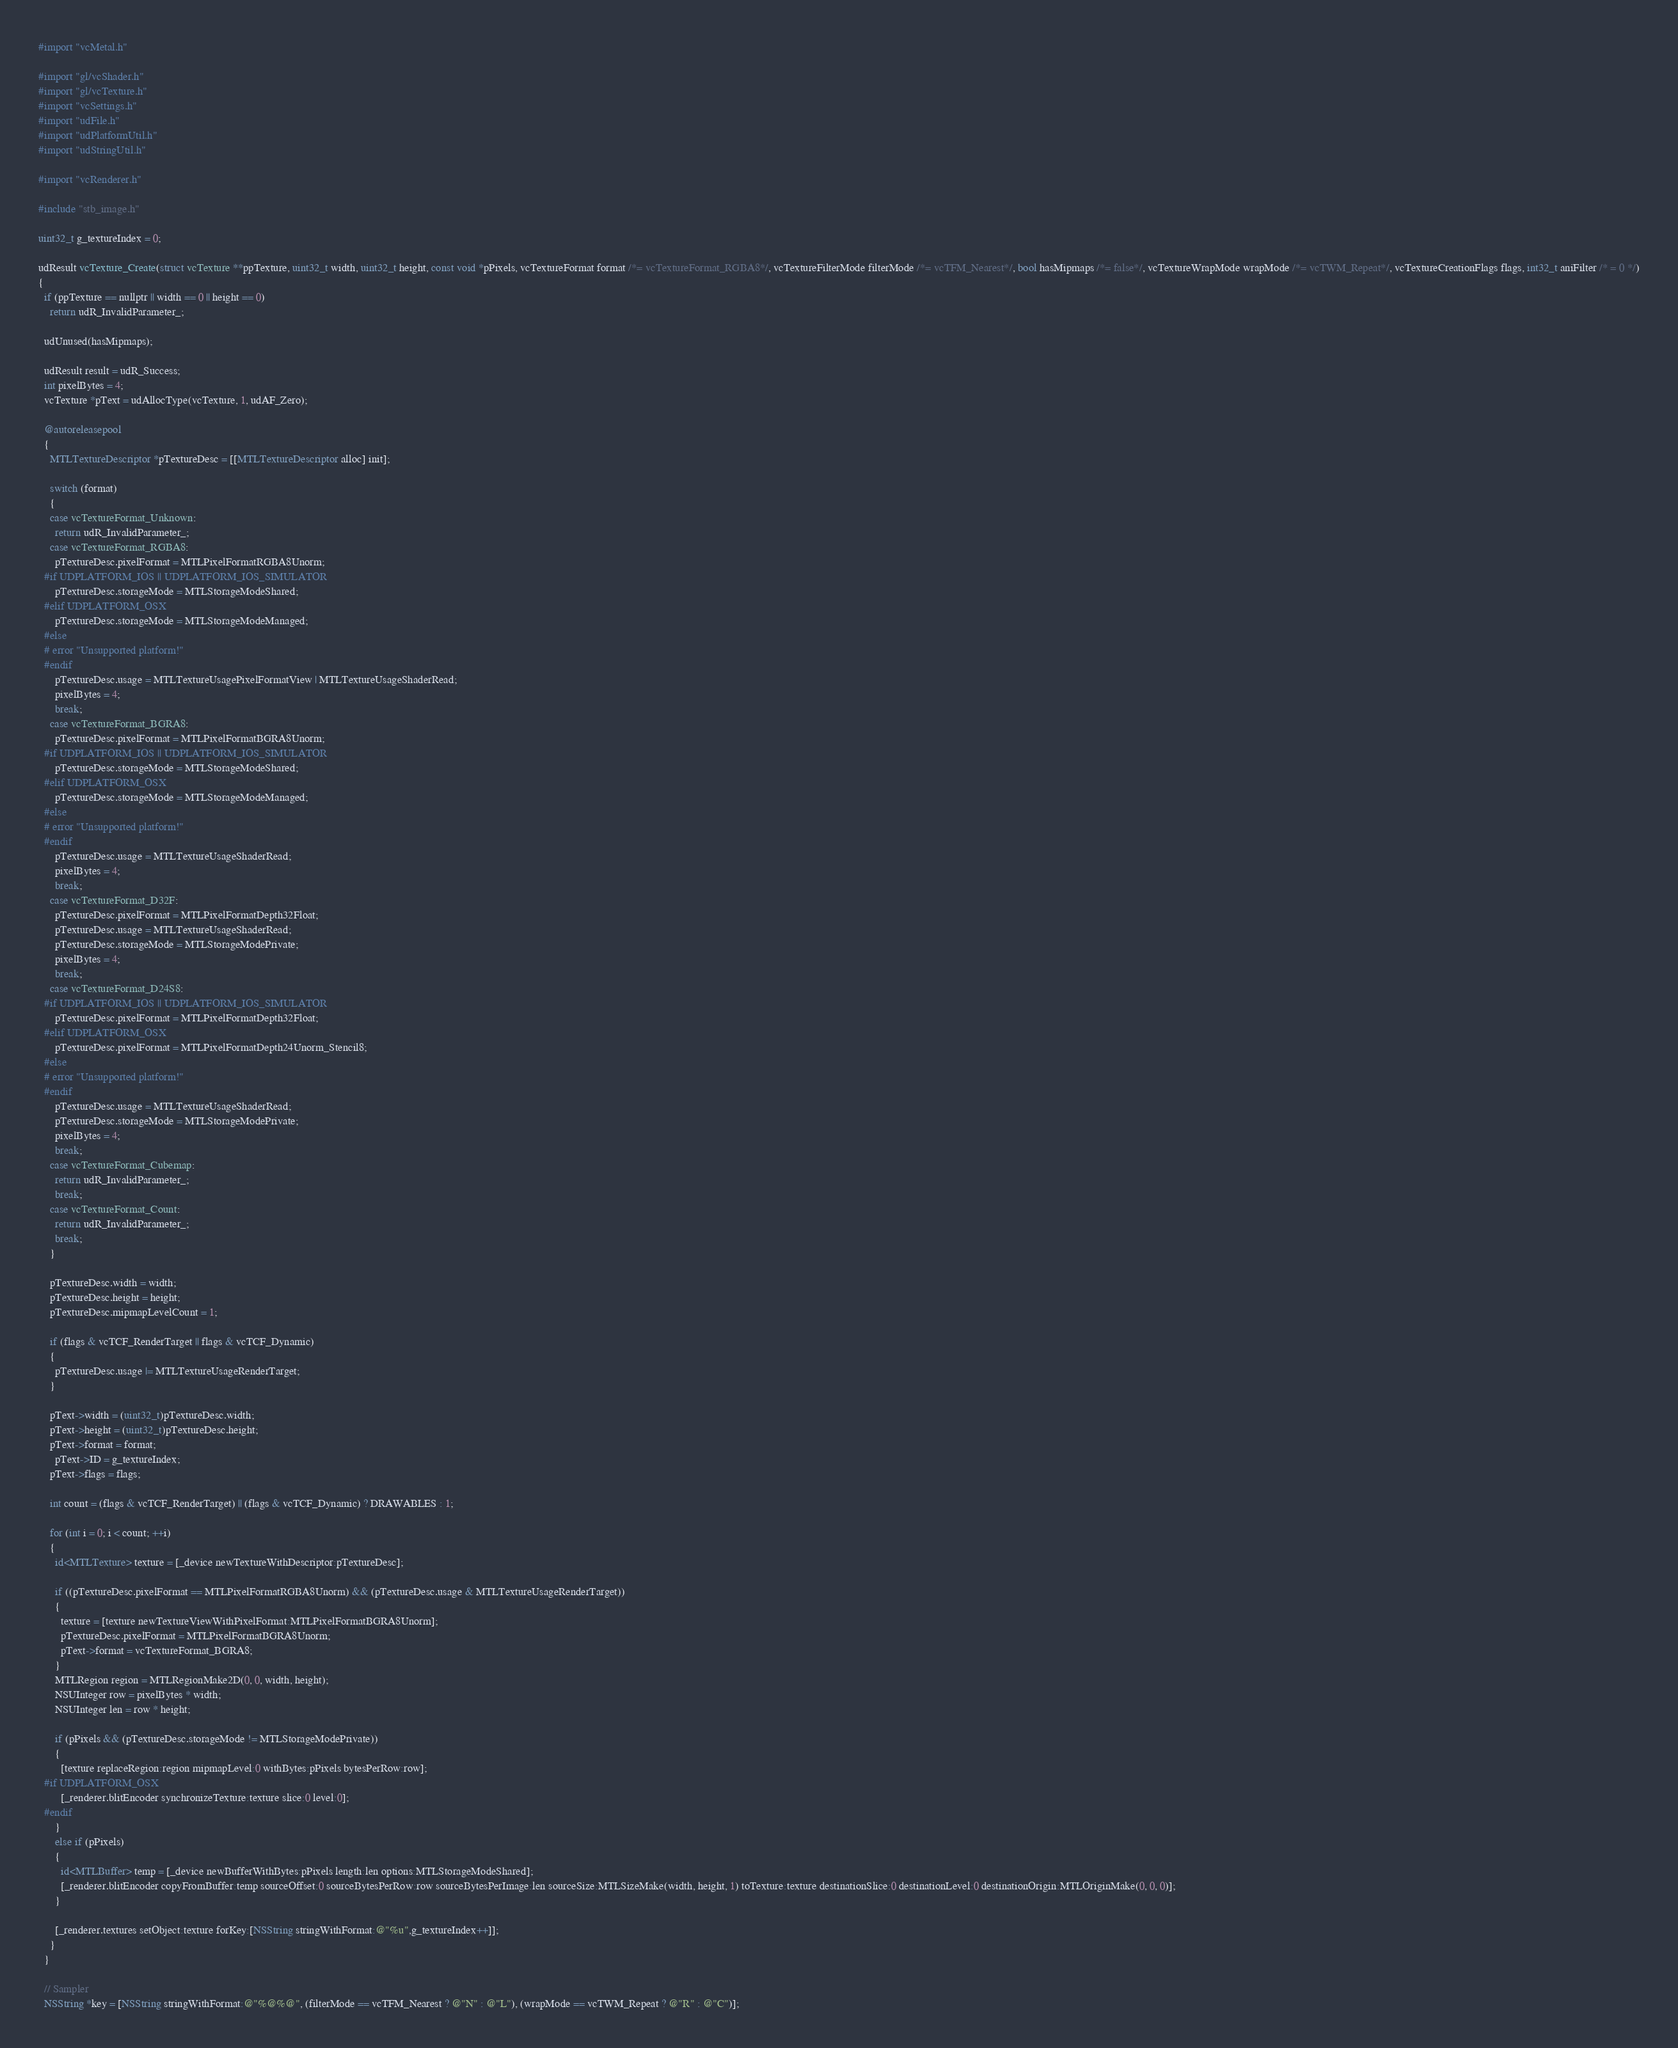<code> <loc_0><loc_0><loc_500><loc_500><_ObjectiveC_>#import "vcMetal.h"

#import "gl/vcShader.h"
#import "gl/vcTexture.h"
#import "vcSettings.h"
#import "udFile.h"
#import "udPlatformUtil.h"
#import "udStringUtil.h"

#import "vcRenderer.h"

#include "stb_image.h"

uint32_t g_textureIndex = 0;

udResult vcTexture_Create(struct vcTexture **ppTexture, uint32_t width, uint32_t height, const void *pPixels, vcTextureFormat format /*= vcTextureFormat_RGBA8*/, vcTextureFilterMode filterMode /*= vcTFM_Nearest*/, bool hasMipmaps /*= false*/, vcTextureWrapMode wrapMode /*= vcTWM_Repeat*/, vcTextureCreationFlags flags, int32_t aniFilter /* = 0 */)
{
  if (ppTexture == nullptr || width == 0 || height == 0)
    return udR_InvalidParameter_;

  udUnused(hasMipmaps);

  udResult result = udR_Success;
  int pixelBytes = 4;
  vcTexture *pText = udAllocType(vcTexture, 1, udAF_Zero);

  @autoreleasepool
  {
    MTLTextureDescriptor *pTextureDesc = [[MTLTextureDescriptor alloc] init];

    switch (format)
    {
    case vcTextureFormat_Unknown:
      return udR_InvalidParameter_;
    case vcTextureFormat_RGBA8:
      pTextureDesc.pixelFormat = MTLPixelFormatRGBA8Unorm;
  #if UDPLATFORM_IOS || UDPLATFORM_IOS_SIMULATOR
      pTextureDesc.storageMode = MTLStorageModeShared;
  #elif UDPLATFORM_OSX
      pTextureDesc.storageMode = MTLStorageModeManaged;
  #else
  # error "Unsupported platform!"
  #endif
      pTextureDesc.usage = MTLTextureUsagePixelFormatView | MTLTextureUsageShaderRead;
      pixelBytes = 4;
      break;
    case vcTextureFormat_BGRA8:
      pTextureDesc.pixelFormat = MTLPixelFormatBGRA8Unorm;
  #if UDPLATFORM_IOS || UDPLATFORM_IOS_SIMULATOR
      pTextureDesc.storageMode = MTLStorageModeShared;
  #elif UDPLATFORM_OSX
      pTextureDesc.storageMode = MTLStorageModeManaged;
  #else
  # error "Unsupported platform!"
  #endif
      pTextureDesc.usage = MTLTextureUsageShaderRead;
      pixelBytes = 4;
      break;
    case vcTextureFormat_D32F:
      pTextureDesc.pixelFormat = MTLPixelFormatDepth32Float;
      pTextureDesc.usage = MTLTextureUsageShaderRead;
      pTextureDesc.storageMode = MTLStorageModePrivate;
      pixelBytes = 4;
      break;
    case vcTextureFormat_D24S8:
  #if UDPLATFORM_IOS || UDPLATFORM_IOS_SIMULATOR
      pTextureDesc.pixelFormat = MTLPixelFormatDepth32Float;
  #elif UDPLATFORM_OSX
      pTextureDesc.pixelFormat = MTLPixelFormatDepth24Unorm_Stencil8;
  #else
  # error "Unsupported platform!"
  #endif
      pTextureDesc.usage = MTLTextureUsageShaderRead;
      pTextureDesc.storageMode = MTLStorageModePrivate;
      pixelBytes = 4;
      break;
    case vcTextureFormat_Cubemap:
      return udR_InvalidParameter_;
      break;
    case vcTextureFormat_Count:
      return udR_InvalidParameter_;
      break;
    }

    pTextureDesc.width = width;
    pTextureDesc.height = height;
    pTextureDesc.mipmapLevelCount = 1;

    if (flags & vcTCF_RenderTarget || flags & vcTCF_Dynamic)
    {
      pTextureDesc.usage |= MTLTextureUsageRenderTarget;
    }

    pText->width = (uint32_t)pTextureDesc.width;
    pText->height = (uint32_t)pTextureDesc.height;
    pText->format = format;
      pText->ID = g_textureIndex;
    pText->flags = flags;

    int count = (flags & vcTCF_RenderTarget) || (flags & vcTCF_Dynamic) ? DRAWABLES : 1;
    
    for (int i = 0; i < count; ++i)
    {
      id<MTLTexture> texture = [_device newTextureWithDescriptor:pTextureDesc];
      
      if ((pTextureDesc.pixelFormat == MTLPixelFormatRGBA8Unorm) && (pTextureDesc.usage & MTLTextureUsageRenderTarget))
      {
        texture = [texture newTextureViewWithPixelFormat:MTLPixelFormatBGRA8Unorm];
        pTextureDesc.pixelFormat = MTLPixelFormatBGRA8Unorm;
        pText->format = vcTextureFormat_BGRA8;
      }
      MTLRegion region = MTLRegionMake2D(0, 0, width, height);
      NSUInteger row = pixelBytes * width;
      NSUInteger len = row * height;
      
      if (pPixels && (pTextureDesc.storageMode != MTLStorageModePrivate))
      {
        [texture replaceRegion:region mipmapLevel:0 withBytes:pPixels bytesPerRow:row];
  #if UDPLATFORM_OSX
        [_renderer.blitEncoder synchronizeTexture:texture slice:0 level:0];
  #endif
      }
      else if (pPixels)
      {
        id<MTLBuffer> temp = [_device newBufferWithBytes:pPixels length:len options:MTLStorageModeShared];
        [_renderer.blitEncoder copyFromBuffer:temp sourceOffset:0 sourceBytesPerRow:row sourceBytesPerImage:len sourceSize:MTLSizeMake(width, height, 1) toTexture:texture destinationSlice:0 destinationLevel:0 destinationOrigin:MTLOriginMake(0, 0, 0)];
      }
      
      [_renderer.textures setObject:texture forKey:[NSString stringWithFormat:@"%u",g_textureIndex++]];
    }
  }
  
  // Sampler
  NSString *key = [NSString stringWithFormat:@"%@%@", (filterMode == vcTFM_Nearest ? @"N" : @"L"), (wrapMode == vcTWM_Repeat ? @"R" : @"C")];</code> 